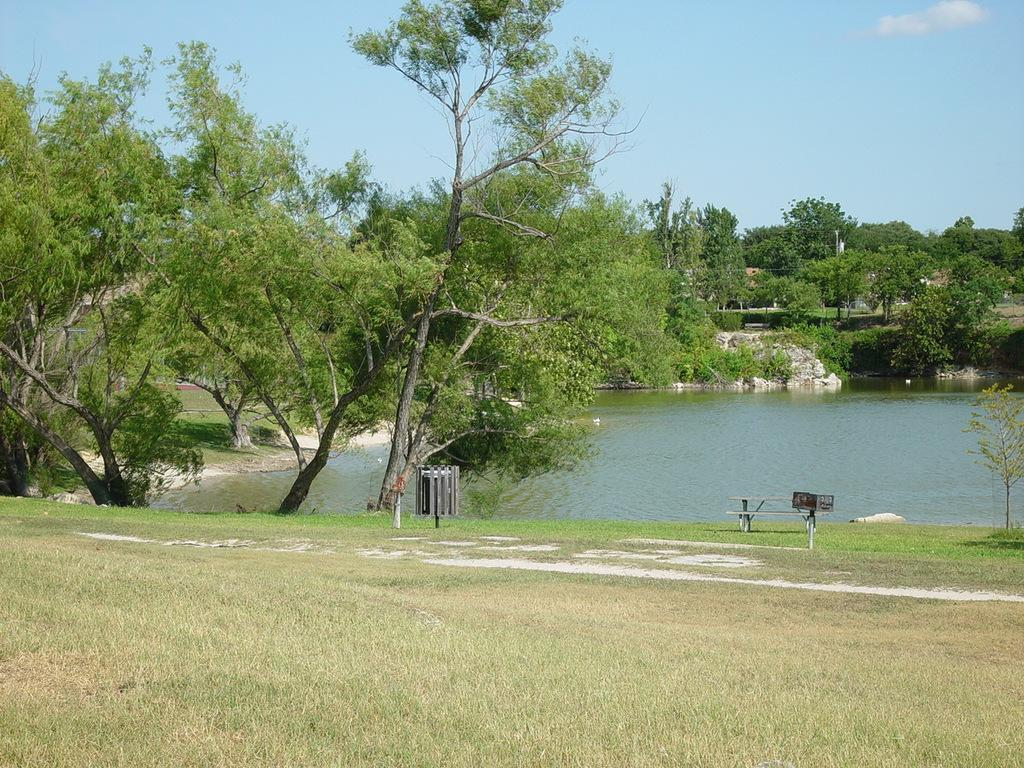What type of body of water is on the right side of the image? There is a lake on the right side of the image. What can be seen in the background of the image? There are trees and the sky visible in the background of the image. What type of vegetation is at the bottom of the image? There is grass at the bottom of the image. How many oranges are hanging from the trees in the image? There are no oranges present in the image; it features a lake, trees, and grass. Can you tell me what the trees are talking about in the image? Trees do not have the ability to talk, so there is no conversation between them in the image. 